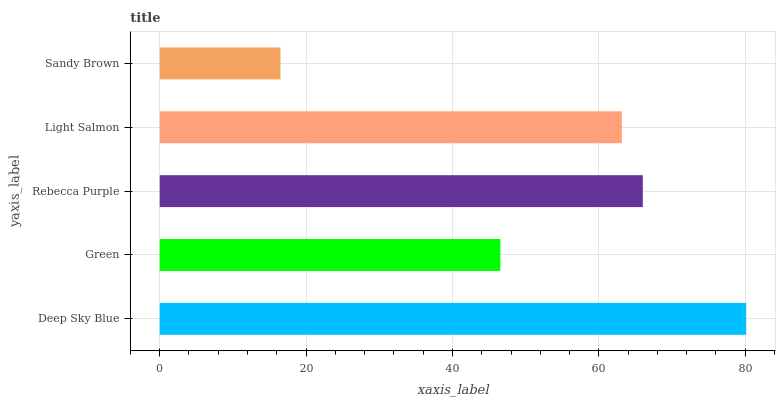Is Sandy Brown the minimum?
Answer yes or no. Yes. Is Deep Sky Blue the maximum?
Answer yes or no. Yes. Is Green the minimum?
Answer yes or no. No. Is Green the maximum?
Answer yes or no. No. Is Deep Sky Blue greater than Green?
Answer yes or no. Yes. Is Green less than Deep Sky Blue?
Answer yes or no. Yes. Is Green greater than Deep Sky Blue?
Answer yes or no. No. Is Deep Sky Blue less than Green?
Answer yes or no. No. Is Light Salmon the high median?
Answer yes or no. Yes. Is Light Salmon the low median?
Answer yes or no. Yes. Is Green the high median?
Answer yes or no. No. Is Deep Sky Blue the low median?
Answer yes or no. No. 